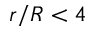<formula> <loc_0><loc_0><loc_500><loc_500>r / R < 4</formula> 